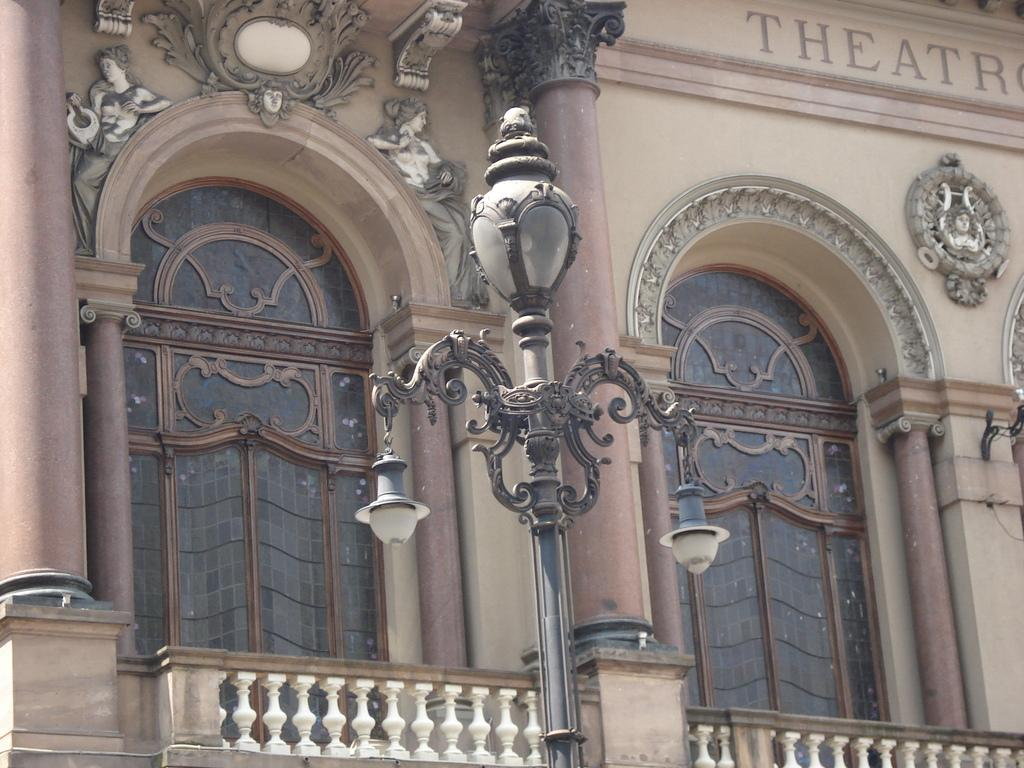What is the main structure in the image? There is a pole in the image. What other features can be seen in the image? There are lights, railings, pillars, arches, and a designed wall in the image. What is written on the wall in the image? There is something written on the wall in the image. How does the pin coil around the pollution in the image? There is no pin or pollution present in the image. 